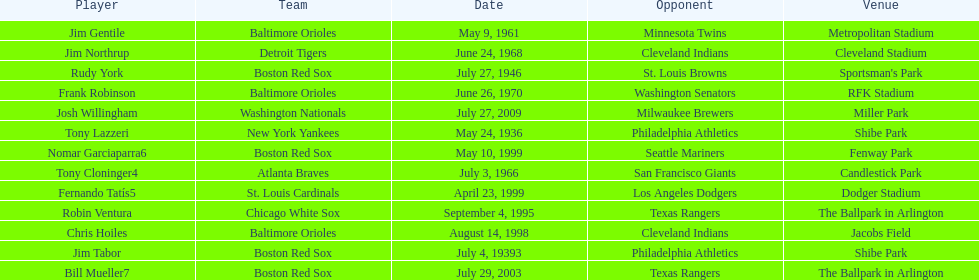What is the name of the player for the new york yankees in 1936? Tony Lazzeri. 